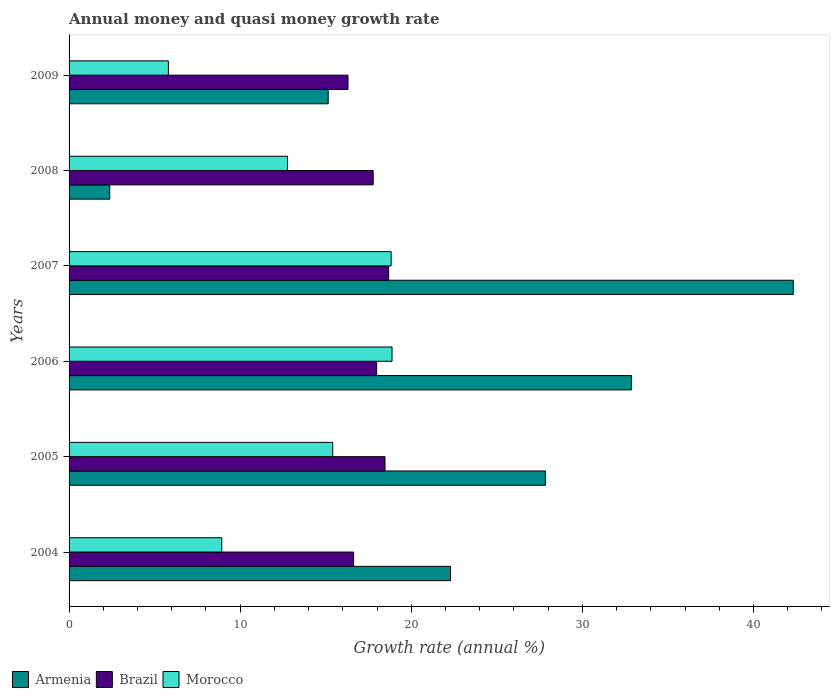Are the number of bars per tick equal to the number of legend labels?
Your answer should be compact. Yes. Are the number of bars on each tick of the Y-axis equal?
Make the answer very short. Yes. How many bars are there on the 2nd tick from the bottom?
Your response must be concise. 3. In how many cases, is the number of bars for a given year not equal to the number of legend labels?
Your answer should be very brief. 0. What is the growth rate in Armenia in 2005?
Ensure brevity in your answer.  27.84. Across all years, what is the maximum growth rate in Armenia?
Offer a very short reply. 42.33. Across all years, what is the minimum growth rate in Armenia?
Make the answer very short. 2.38. What is the total growth rate in Armenia in the graph?
Your answer should be very brief. 142.87. What is the difference between the growth rate in Armenia in 2007 and that in 2009?
Keep it short and to the point. 27.18. What is the difference between the growth rate in Brazil in 2004 and the growth rate in Morocco in 2006?
Keep it short and to the point. -2.25. What is the average growth rate in Brazil per year?
Provide a short and direct response. 17.64. In the year 2007, what is the difference between the growth rate in Armenia and growth rate in Brazil?
Keep it short and to the point. 23.65. What is the ratio of the growth rate in Armenia in 2008 to that in 2009?
Provide a succinct answer. 0.16. Is the difference between the growth rate in Armenia in 2006 and 2008 greater than the difference between the growth rate in Brazil in 2006 and 2008?
Offer a terse response. Yes. What is the difference between the highest and the second highest growth rate in Brazil?
Offer a terse response. 0.21. What is the difference between the highest and the lowest growth rate in Morocco?
Give a very brief answer. 13.07. In how many years, is the growth rate in Armenia greater than the average growth rate in Armenia taken over all years?
Provide a short and direct response. 3. What does the 2nd bar from the top in 2008 represents?
Give a very brief answer. Brazil. What does the 3rd bar from the bottom in 2006 represents?
Your answer should be compact. Morocco. How many bars are there?
Offer a very short reply. 18. Does the graph contain any zero values?
Your response must be concise. No. Does the graph contain grids?
Provide a short and direct response. No. How many legend labels are there?
Give a very brief answer. 3. How are the legend labels stacked?
Make the answer very short. Horizontal. What is the title of the graph?
Offer a very short reply. Annual money and quasi money growth rate. Does "United States" appear as one of the legend labels in the graph?
Your answer should be compact. No. What is the label or title of the X-axis?
Your answer should be compact. Growth rate (annual %). What is the Growth rate (annual %) of Armenia in 2004?
Offer a terse response. 22.29. What is the Growth rate (annual %) of Brazil in 2004?
Provide a succinct answer. 16.63. What is the Growth rate (annual %) of Morocco in 2004?
Make the answer very short. 8.92. What is the Growth rate (annual %) in Armenia in 2005?
Provide a short and direct response. 27.84. What is the Growth rate (annual %) of Brazil in 2005?
Make the answer very short. 18.47. What is the Growth rate (annual %) of Morocco in 2005?
Offer a terse response. 15.41. What is the Growth rate (annual %) in Armenia in 2006?
Provide a short and direct response. 32.88. What is the Growth rate (annual %) in Brazil in 2006?
Your answer should be compact. 17.98. What is the Growth rate (annual %) of Morocco in 2006?
Provide a short and direct response. 18.88. What is the Growth rate (annual %) of Armenia in 2007?
Your answer should be very brief. 42.33. What is the Growth rate (annual %) of Brazil in 2007?
Ensure brevity in your answer.  18.68. What is the Growth rate (annual %) in Morocco in 2007?
Make the answer very short. 18.83. What is the Growth rate (annual %) in Armenia in 2008?
Ensure brevity in your answer.  2.38. What is the Growth rate (annual %) of Brazil in 2008?
Offer a terse response. 17.78. What is the Growth rate (annual %) of Morocco in 2008?
Ensure brevity in your answer.  12.77. What is the Growth rate (annual %) of Armenia in 2009?
Give a very brief answer. 15.15. What is the Growth rate (annual %) of Brazil in 2009?
Your answer should be compact. 16.3. What is the Growth rate (annual %) of Morocco in 2009?
Make the answer very short. 5.8. Across all years, what is the maximum Growth rate (annual %) of Armenia?
Offer a terse response. 42.33. Across all years, what is the maximum Growth rate (annual %) of Brazil?
Provide a short and direct response. 18.68. Across all years, what is the maximum Growth rate (annual %) of Morocco?
Offer a very short reply. 18.88. Across all years, what is the minimum Growth rate (annual %) of Armenia?
Offer a very short reply. 2.38. Across all years, what is the minimum Growth rate (annual %) in Brazil?
Your answer should be very brief. 16.3. Across all years, what is the minimum Growth rate (annual %) in Morocco?
Make the answer very short. 5.8. What is the total Growth rate (annual %) of Armenia in the graph?
Your response must be concise. 142.87. What is the total Growth rate (annual %) in Brazil in the graph?
Offer a terse response. 105.83. What is the total Growth rate (annual %) of Morocco in the graph?
Your response must be concise. 80.61. What is the difference between the Growth rate (annual %) of Armenia in 2004 and that in 2005?
Your response must be concise. -5.55. What is the difference between the Growth rate (annual %) of Brazil in 2004 and that in 2005?
Offer a terse response. -1.84. What is the difference between the Growth rate (annual %) of Morocco in 2004 and that in 2005?
Your answer should be compact. -6.49. What is the difference between the Growth rate (annual %) of Armenia in 2004 and that in 2006?
Provide a short and direct response. -10.58. What is the difference between the Growth rate (annual %) in Brazil in 2004 and that in 2006?
Your response must be concise. -1.35. What is the difference between the Growth rate (annual %) in Morocco in 2004 and that in 2006?
Offer a terse response. -9.95. What is the difference between the Growth rate (annual %) of Armenia in 2004 and that in 2007?
Your answer should be compact. -20.04. What is the difference between the Growth rate (annual %) of Brazil in 2004 and that in 2007?
Keep it short and to the point. -2.05. What is the difference between the Growth rate (annual %) in Morocco in 2004 and that in 2007?
Ensure brevity in your answer.  -9.9. What is the difference between the Growth rate (annual %) in Armenia in 2004 and that in 2008?
Provide a short and direct response. 19.91. What is the difference between the Growth rate (annual %) of Brazil in 2004 and that in 2008?
Make the answer very short. -1.15. What is the difference between the Growth rate (annual %) in Morocco in 2004 and that in 2008?
Make the answer very short. -3.84. What is the difference between the Growth rate (annual %) of Armenia in 2004 and that in 2009?
Your answer should be compact. 7.15. What is the difference between the Growth rate (annual %) of Brazil in 2004 and that in 2009?
Your response must be concise. 0.33. What is the difference between the Growth rate (annual %) in Morocco in 2004 and that in 2009?
Offer a terse response. 3.12. What is the difference between the Growth rate (annual %) in Armenia in 2005 and that in 2006?
Provide a succinct answer. -5.04. What is the difference between the Growth rate (annual %) of Brazil in 2005 and that in 2006?
Offer a very short reply. 0.49. What is the difference between the Growth rate (annual %) in Morocco in 2005 and that in 2006?
Provide a short and direct response. -3.47. What is the difference between the Growth rate (annual %) in Armenia in 2005 and that in 2007?
Offer a terse response. -14.49. What is the difference between the Growth rate (annual %) in Brazil in 2005 and that in 2007?
Ensure brevity in your answer.  -0.21. What is the difference between the Growth rate (annual %) in Morocco in 2005 and that in 2007?
Your answer should be compact. -3.41. What is the difference between the Growth rate (annual %) of Armenia in 2005 and that in 2008?
Offer a very short reply. 25.46. What is the difference between the Growth rate (annual %) of Brazil in 2005 and that in 2008?
Your response must be concise. 0.69. What is the difference between the Growth rate (annual %) of Morocco in 2005 and that in 2008?
Your answer should be compact. 2.64. What is the difference between the Growth rate (annual %) in Armenia in 2005 and that in 2009?
Offer a terse response. 12.7. What is the difference between the Growth rate (annual %) of Brazil in 2005 and that in 2009?
Your answer should be very brief. 2.16. What is the difference between the Growth rate (annual %) of Morocco in 2005 and that in 2009?
Ensure brevity in your answer.  9.61. What is the difference between the Growth rate (annual %) in Armenia in 2006 and that in 2007?
Provide a short and direct response. -9.45. What is the difference between the Growth rate (annual %) of Brazil in 2006 and that in 2007?
Your answer should be compact. -0.7. What is the difference between the Growth rate (annual %) of Morocco in 2006 and that in 2007?
Your response must be concise. 0.05. What is the difference between the Growth rate (annual %) of Armenia in 2006 and that in 2008?
Your answer should be compact. 30.5. What is the difference between the Growth rate (annual %) in Brazil in 2006 and that in 2008?
Provide a short and direct response. 0.2. What is the difference between the Growth rate (annual %) of Morocco in 2006 and that in 2008?
Give a very brief answer. 6.11. What is the difference between the Growth rate (annual %) in Armenia in 2006 and that in 2009?
Provide a succinct answer. 17.73. What is the difference between the Growth rate (annual %) in Brazil in 2006 and that in 2009?
Your answer should be compact. 1.67. What is the difference between the Growth rate (annual %) in Morocco in 2006 and that in 2009?
Your answer should be compact. 13.07. What is the difference between the Growth rate (annual %) in Armenia in 2007 and that in 2008?
Ensure brevity in your answer.  39.95. What is the difference between the Growth rate (annual %) of Brazil in 2007 and that in 2008?
Offer a very short reply. 0.9. What is the difference between the Growth rate (annual %) in Morocco in 2007 and that in 2008?
Give a very brief answer. 6.06. What is the difference between the Growth rate (annual %) of Armenia in 2007 and that in 2009?
Your response must be concise. 27.18. What is the difference between the Growth rate (annual %) in Brazil in 2007 and that in 2009?
Provide a succinct answer. 2.38. What is the difference between the Growth rate (annual %) of Morocco in 2007 and that in 2009?
Give a very brief answer. 13.02. What is the difference between the Growth rate (annual %) in Armenia in 2008 and that in 2009?
Your response must be concise. -12.77. What is the difference between the Growth rate (annual %) of Brazil in 2008 and that in 2009?
Make the answer very short. 1.47. What is the difference between the Growth rate (annual %) of Morocco in 2008 and that in 2009?
Provide a succinct answer. 6.96. What is the difference between the Growth rate (annual %) in Armenia in 2004 and the Growth rate (annual %) in Brazil in 2005?
Keep it short and to the point. 3.83. What is the difference between the Growth rate (annual %) in Armenia in 2004 and the Growth rate (annual %) in Morocco in 2005?
Make the answer very short. 6.88. What is the difference between the Growth rate (annual %) of Brazil in 2004 and the Growth rate (annual %) of Morocco in 2005?
Make the answer very short. 1.22. What is the difference between the Growth rate (annual %) in Armenia in 2004 and the Growth rate (annual %) in Brazil in 2006?
Keep it short and to the point. 4.32. What is the difference between the Growth rate (annual %) of Armenia in 2004 and the Growth rate (annual %) of Morocco in 2006?
Offer a very short reply. 3.42. What is the difference between the Growth rate (annual %) of Brazil in 2004 and the Growth rate (annual %) of Morocco in 2006?
Keep it short and to the point. -2.25. What is the difference between the Growth rate (annual %) of Armenia in 2004 and the Growth rate (annual %) of Brazil in 2007?
Offer a terse response. 3.61. What is the difference between the Growth rate (annual %) in Armenia in 2004 and the Growth rate (annual %) in Morocco in 2007?
Make the answer very short. 3.47. What is the difference between the Growth rate (annual %) in Brazil in 2004 and the Growth rate (annual %) in Morocco in 2007?
Keep it short and to the point. -2.2. What is the difference between the Growth rate (annual %) in Armenia in 2004 and the Growth rate (annual %) in Brazil in 2008?
Give a very brief answer. 4.52. What is the difference between the Growth rate (annual %) in Armenia in 2004 and the Growth rate (annual %) in Morocco in 2008?
Provide a short and direct response. 9.53. What is the difference between the Growth rate (annual %) of Brazil in 2004 and the Growth rate (annual %) of Morocco in 2008?
Your response must be concise. 3.86. What is the difference between the Growth rate (annual %) in Armenia in 2004 and the Growth rate (annual %) in Brazil in 2009?
Provide a short and direct response. 5.99. What is the difference between the Growth rate (annual %) in Armenia in 2004 and the Growth rate (annual %) in Morocco in 2009?
Offer a terse response. 16.49. What is the difference between the Growth rate (annual %) in Brazil in 2004 and the Growth rate (annual %) in Morocco in 2009?
Offer a terse response. 10.83. What is the difference between the Growth rate (annual %) in Armenia in 2005 and the Growth rate (annual %) in Brazil in 2006?
Offer a terse response. 9.87. What is the difference between the Growth rate (annual %) of Armenia in 2005 and the Growth rate (annual %) of Morocco in 2006?
Offer a terse response. 8.96. What is the difference between the Growth rate (annual %) of Brazil in 2005 and the Growth rate (annual %) of Morocco in 2006?
Your answer should be compact. -0.41. What is the difference between the Growth rate (annual %) in Armenia in 2005 and the Growth rate (annual %) in Brazil in 2007?
Give a very brief answer. 9.16. What is the difference between the Growth rate (annual %) in Armenia in 2005 and the Growth rate (annual %) in Morocco in 2007?
Ensure brevity in your answer.  9.02. What is the difference between the Growth rate (annual %) in Brazil in 2005 and the Growth rate (annual %) in Morocco in 2007?
Your answer should be compact. -0.36. What is the difference between the Growth rate (annual %) of Armenia in 2005 and the Growth rate (annual %) of Brazil in 2008?
Make the answer very short. 10.07. What is the difference between the Growth rate (annual %) in Armenia in 2005 and the Growth rate (annual %) in Morocco in 2008?
Offer a terse response. 15.07. What is the difference between the Growth rate (annual %) in Brazil in 2005 and the Growth rate (annual %) in Morocco in 2008?
Make the answer very short. 5.7. What is the difference between the Growth rate (annual %) of Armenia in 2005 and the Growth rate (annual %) of Brazil in 2009?
Make the answer very short. 11.54. What is the difference between the Growth rate (annual %) of Armenia in 2005 and the Growth rate (annual %) of Morocco in 2009?
Make the answer very short. 22.04. What is the difference between the Growth rate (annual %) in Brazil in 2005 and the Growth rate (annual %) in Morocco in 2009?
Your answer should be very brief. 12.66. What is the difference between the Growth rate (annual %) of Armenia in 2006 and the Growth rate (annual %) of Brazil in 2007?
Keep it short and to the point. 14.2. What is the difference between the Growth rate (annual %) of Armenia in 2006 and the Growth rate (annual %) of Morocco in 2007?
Your response must be concise. 14.05. What is the difference between the Growth rate (annual %) in Brazil in 2006 and the Growth rate (annual %) in Morocco in 2007?
Your answer should be very brief. -0.85. What is the difference between the Growth rate (annual %) in Armenia in 2006 and the Growth rate (annual %) in Brazil in 2008?
Give a very brief answer. 15.1. What is the difference between the Growth rate (annual %) in Armenia in 2006 and the Growth rate (annual %) in Morocco in 2008?
Provide a succinct answer. 20.11. What is the difference between the Growth rate (annual %) in Brazil in 2006 and the Growth rate (annual %) in Morocco in 2008?
Provide a short and direct response. 5.21. What is the difference between the Growth rate (annual %) in Armenia in 2006 and the Growth rate (annual %) in Brazil in 2009?
Provide a short and direct response. 16.57. What is the difference between the Growth rate (annual %) in Armenia in 2006 and the Growth rate (annual %) in Morocco in 2009?
Give a very brief answer. 27.07. What is the difference between the Growth rate (annual %) in Brazil in 2006 and the Growth rate (annual %) in Morocco in 2009?
Keep it short and to the point. 12.17. What is the difference between the Growth rate (annual %) in Armenia in 2007 and the Growth rate (annual %) in Brazil in 2008?
Provide a short and direct response. 24.55. What is the difference between the Growth rate (annual %) of Armenia in 2007 and the Growth rate (annual %) of Morocco in 2008?
Give a very brief answer. 29.56. What is the difference between the Growth rate (annual %) of Brazil in 2007 and the Growth rate (annual %) of Morocco in 2008?
Ensure brevity in your answer.  5.91. What is the difference between the Growth rate (annual %) in Armenia in 2007 and the Growth rate (annual %) in Brazil in 2009?
Offer a terse response. 26.03. What is the difference between the Growth rate (annual %) of Armenia in 2007 and the Growth rate (annual %) of Morocco in 2009?
Provide a short and direct response. 36.52. What is the difference between the Growth rate (annual %) of Brazil in 2007 and the Growth rate (annual %) of Morocco in 2009?
Keep it short and to the point. 12.87. What is the difference between the Growth rate (annual %) of Armenia in 2008 and the Growth rate (annual %) of Brazil in 2009?
Offer a terse response. -13.92. What is the difference between the Growth rate (annual %) in Armenia in 2008 and the Growth rate (annual %) in Morocco in 2009?
Provide a succinct answer. -3.43. What is the difference between the Growth rate (annual %) in Brazil in 2008 and the Growth rate (annual %) in Morocco in 2009?
Give a very brief answer. 11.97. What is the average Growth rate (annual %) of Armenia per year?
Your response must be concise. 23.81. What is the average Growth rate (annual %) of Brazil per year?
Provide a succinct answer. 17.64. What is the average Growth rate (annual %) in Morocco per year?
Keep it short and to the point. 13.44. In the year 2004, what is the difference between the Growth rate (annual %) in Armenia and Growth rate (annual %) in Brazil?
Offer a terse response. 5.66. In the year 2004, what is the difference between the Growth rate (annual %) of Armenia and Growth rate (annual %) of Morocco?
Provide a short and direct response. 13.37. In the year 2004, what is the difference between the Growth rate (annual %) in Brazil and Growth rate (annual %) in Morocco?
Give a very brief answer. 7.71. In the year 2005, what is the difference between the Growth rate (annual %) in Armenia and Growth rate (annual %) in Brazil?
Keep it short and to the point. 9.37. In the year 2005, what is the difference between the Growth rate (annual %) in Armenia and Growth rate (annual %) in Morocco?
Your answer should be very brief. 12.43. In the year 2005, what is the difference between the Growth rate (annual %) in Brazil and Growth rate (annual %) in Morocco?
Give a very brief answer. 3.06. In the year 2006, what is the difference between the Growth rate (annual %) in Armenia and Growth rate (annual %) in Brazil?
Provide a short and direct response. 14.9. In the year 2006, what is the difference between the Growth rate (annual %) in Armenia and Growth rate (annual %) in Morocco?
Offer a very short reply. 14. In the year 2006, what is the difference between the Growth rate (annual %) of Brazil and Growth rate (annual %) of Morocco?
Provide a short and direct response. -0.9. In the year 2007, what is the difference between the Growth rate (annual %) of Armenia and Growth rate (annual %) of Brazil?
Your response must be concise. 23.65. In the year 2007, what is the difference between the Growth rate (annual %) in Armenia and Growth rate (annual %) in Morocco?
Offer a terse response. 23.5. In the year 2007, what is the difference between the Growth rate (annual %) of Brazil and Growth rate (annual %) of Morocco?
Offer a very short reply. -0.15. In the year 2008, what is the difference between the Growth rate (annual %) in Armenia and Growth rate (annual %) in Brazil?
Provide a short and direct response. -15.4. In the year 2008, what is the difference between the Growth rate (annual %) of Armenia and Growth rate (annual %) of Morocco?
Ensure brevity in your answer.  -10.39. In the year 2008, what is the difference between the Growth rate (annual %) of Brazil and Growth rate (annual %) of Morocco?
Offer a very short reply. 5.01. In the year 2009, what is the difference between the Growth rate (annual %) of Armenia and Growth rate (annual %) of Brazil?
Provide a short and direct response. -1.16. In the year 2009, what is the difference between the Growth rate (annual %) of Armenia and Growth rate (annual %) of Morocco?
Ensure brevity in your answer.  9.34. In the year 2009, what is the difference between the Growth rate (annual %) in Brazil and Growth rate (annual %) in Morocco?
Provide a short and direct response. 10.5. What is the ratio of the Growth rate (annual %) of Armenia in 2004 to that in 2005?
Make the answer very short. 0.8. What is the ratio of the Growth rate (annual %) of Brazil in 2004 to that in 2005?
Your answer should be very brief. 0.9. What is the ratio of the Growth rate (annual %) in Morocco in 2004 to that in 2005?
Make the answer very short. 0.58. What is the ratio of the Growth rate (annual %) in Armenia in 2004 to that in 2006?
Give a very brief answer. 0.68. What is the ratio of the Growth rate (annual %) of Brazil in 2004 to that in 2006?
Ensure brevity in your answer.  0.93. What is the ratio of the Growth rate (annual %) of Morocco in 2004 to that in 2006?
Keep it short and to the point. 0.47. What is the ratio of the Growth rate (annual %) in Armenia in 2004 to that in 2007?
Make the answer very short. 0.53. What is the ratio of the Growth rate (annual %) of Brazil in 2004 to that in 2007?
Your answer should be very brief. 0.89. What is the ratio of the Growth rate (annual %) in Morocco in 2004 to that in 2007?
Your answer should be very brief. 0.47. What is the ratio of the Growth rate (annual %) of Armenia in 2004 to that in 2008?
Your answer should be compact. 9.37. What is the ratio of the Growth rate (annual %) of Brazil in 2004 to that in 2008?
Offer a very short reply. 0.94. What is the ratio of the Growth rate (annual %) in Morocco in 2004 to that in 2008?
Provide a succinct answer. 0.7. What is the ratio of the Growth rate (annual %) in Armenia in 2004 to that in 2009?
Ensure brevity in your answer.  1.47. What is the ratio of the Growth rate (annual %) of Brazil in 2004 to that in 2009?
Give a very brief answer. 1.02. What is the ratio of the Growth rate (annual %) in Morocco in 2004 to that in 2009?
Ensure brevity in your answer.  1.54. What is the ratio of the Growth rate (annual %) in Armenia in 2005 to that in 2006?
Provide a short and direct response. 0.85. What is the ratio of the Growth rate (annual %) of Brazil in 2005 to that in 2006?
Provide a short and direct response. 1.03. What is the ratio of the Growth rate (annual %) of Morocco in 2005 to that in 2006?
Your response must be concise. 0.82. What is the ratio of the Growth rate (annual %) in Armenia in 2005 to that in 2007?
Give a very brief answer. 0.66. What is the ratio of the Growth rate (annual %) of Brazil in 2005 to that in 2007?
Provide a short and direct response. 0.99. What is the ratio of the Growth rate (annual %) of Morocco in 2005 to that in 2007?
Your answer should be very brief. 0.82. What is the ratio of the Growth rate (annual %) of Armenia in 2005 to that in 2008?
Provide a short and direct response. 11.7. What is the ratio of the Growth rate (annual %) of Brazil in 2005 to that in 2008?
Ensure brevity in your answer.  1.04. What is the ratio of the Growth rate (annual %) of Morocco in 2005 to that in 2008?
Ensure brevity in your answer.  1.21. What is the ratio of the Growth rate (annual %) in Armenia in 2005 to that in 2009?
Give a very brief answer. 1.84. What is the ratio of the Growth rate (annual %) of Brazil in 2005 to that in 2009?
Give a very brief answer. 1.13. What is the ratio of the Growth rate (annual %) in Morocco in 2005 to that in 2009?
Your answer should be very brief. 2.65. What is the ratio of the Growth rate (annual %) in Armenia in 2006 to that in 2007?
Provide a succinct answer. 0.78. What is the ratio of the Growth rate (annual %) in Brazil in 2006 to that in 2007?
Provide a short and direct response. 0.96. What is the ratio of the Growth rate (annual %) of Morocco in 2006 to that in 2007?
Give a very brief answer. 1. What is the ratio of the Growth rate (annual %) of Armenia in 2006 to that in 2008?
Make the answer very short. 13.82. What is the ratio of the Growth rate (annual %) of Brazil in 2006 to that in 2008?
Your response must be concise. 1.01. What is the ratio of the Growth rate (annual %) of Morocco in 2006 to that in 2008?
Offer a very short reply. 1.48. What is the ratio of the Growth rate (annual %) of Armenia in 2006 to that in 2009?
Provide a short and direct response. 2.17. What is the ratio of the Growth rate (annual %) of Brazil in 2006 to that in 2009?
Give a very brief answer. 1.1. What is the ratio of the Growth rate (annual %) of Morocco in 2006 to that in 2009?
Your answer should be very brief. 3.25. What is the ratio of the Growth rate (annual %) of Armenia in 2007 to that in 2008?
Offer a terse response. 17.8. What is the ratio of the Growth rate (annual %) in Brazil in 2007 to that in 2008?
Your answer should be compact. 1.05. What is the ratio of the Growth rate (annual %) in Morocco in 2007 to that in 2008?
Your answer should be very brief. 1.47. What is the ratio of the Growth rate (annual %) of Armenia in 2007 to that in 2009?
Keep it short and to the point. 2.79. What is the ratio of the Growth rate (annual %) of Brazil in 2007 to that in 2009?
Make the answer very short. 1.15. What is the ratio of the Growth rate (annual %) of Morocco in 2007 to that in 2009?
Make the answer very short. 3.24. What is the ratio of the Growth rate (annual %) of Armenia in 2008 to that in 2009?
Ensure brevity in your answer.  0.16. What is the ratio of the Growth rate (annual %) of Brazil in 2008 to that in 2009?
Offer a very short reply. 1.09. What is the ratio of the Growth rate (annual %) in Morocco in 2008 to that in 2009?
Keep it short and to the point. 2.2. What is the difference between the highest and the second highest Growth rate (annual %) in Armenia?
Your answer should be compact. 9.45. What is the difference between the highest and the second highest Growth rate (annual %) in Brazil?
Your response must be concise. 0.21. What is the difference between the highest and the second highest Growth rate (annual %) of Morocco?
Give a very brief answer. 0.05. What is the difference between the highest and the lowest Growth rate (annual %) in Armenia?
Your response must be concise. 39.95. What is the difference between the highest and the lowest Growth rate (annual %) in Brazil?
Offer a very short reply. 2.38. What is the difference between the highest and the lowest Growth rate (annual %) of Morocco?
Give a very brief answer. 13.07. 